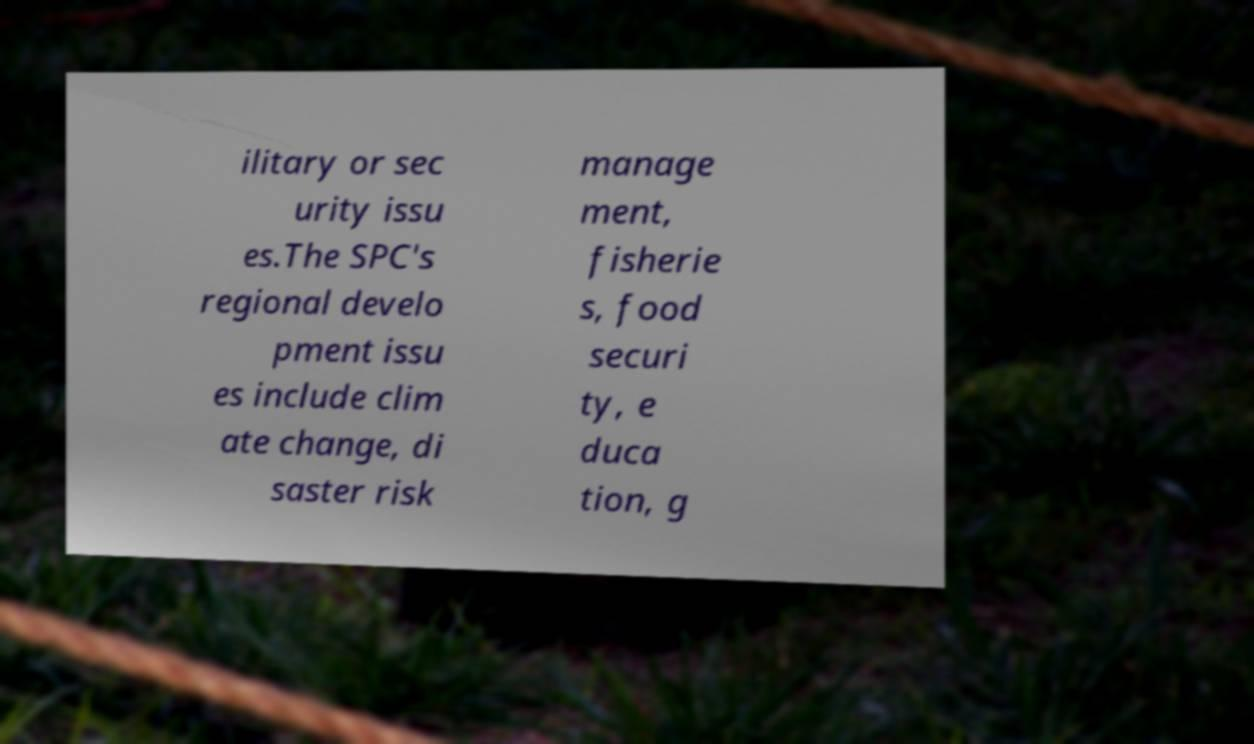Could you extract and type out the text from this image? ilitary or sec urity issu es.The SPC's regional develo pment issu es include clim ate change, di saster risk manage ment, fisherie s, food securi ty, e duca tion, g 